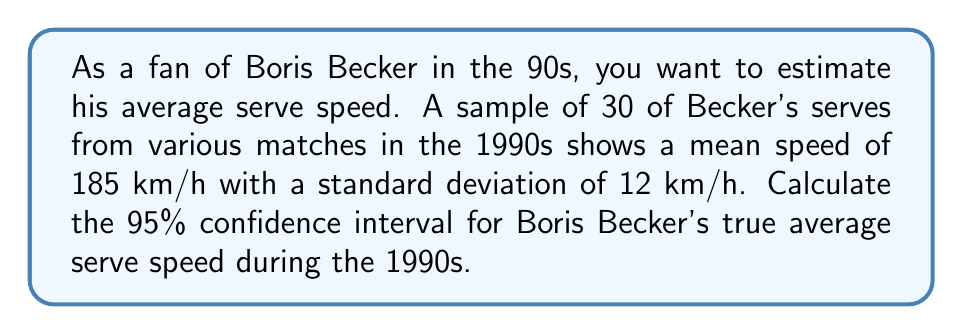Help me with this question. Let's approach this step-by-step:

1) We're given:
   - Sample size (n) = 30
   - Sample mean ($\bar{x}$) = 185 km/h
   - Sample standard deviation (s) = 12 km/h
   - Confidence level = 95%

2) For a 95% confidence interval with n < 30, we use the t-distribution. The formula is:

   $$\bar{x} \pm t_{\alpha/2} \cdot \frac{s}{\sqrt{n}}$$

3) Find the t-value:
   - Degrees of freedom (df) = n - 1 = 29
   - For a 95% CI, $\alpha = 0.05$ and $\alpha/2 = 0.025$
   - From t-table: $t_{0.025,29} \approx 2.045$

4) Calculate the margin of error:

   $$\text{Margin of Error} = t_{\alpha/2} \cdot \frac{s}{\sqrt{n}} = 2.045 \cdot \frac{12}{\sqrt{30}} \approx 4.49$$

5) Calculate the confidence interval:
   
   Lower bound: $185 - 4.49 = 180.51$ km/h
   Upper bound: $185 + 4.49 = 189.49$ km/h

Therefore, we can be 95% confident that Boris Becker's true average serve speed in the 1990s was between 180.51 km/h and 189.49 km/h.
Answer: (180.51, 189.49) km/h 